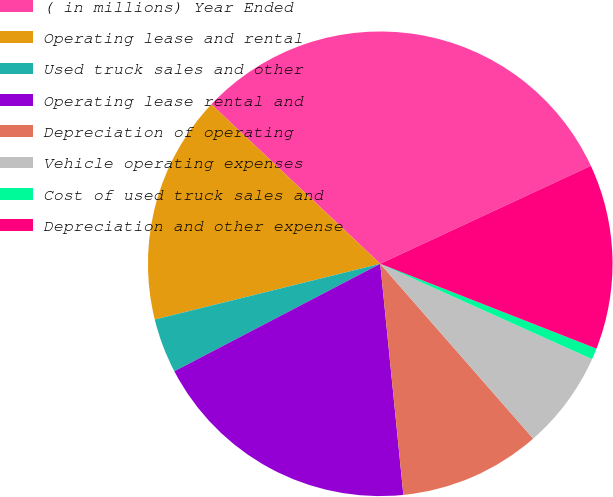Convert chart to OTSL. <chart><loc_0><loc_0><loc_500><loc_500><pie_chart><fcel>( in millions) Year Ended<fcel>Operating lease and rental<fcel>Used truck sales and other<fcel>Operating lease rental and<fcel>Depreciation of operating<fcel>Vehicle operating expenses<fcel>Cost of used truck sales and<fcel>Depreciation and other expense<nl><fcel>31.03%<fcel>15.9%<fcel>3.8%<fcel>18.93%<fcel>9.85%<fcel>6.83%<fcel>0.78%<fcel>12.88%<nl></chart> 